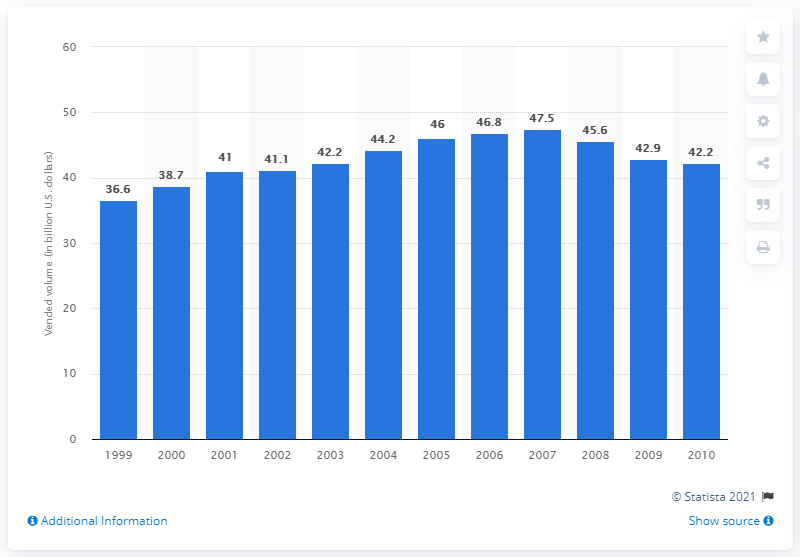Identify some key points in this picture. In 1999, the sales volume of vending machines was 36.6 million units. 